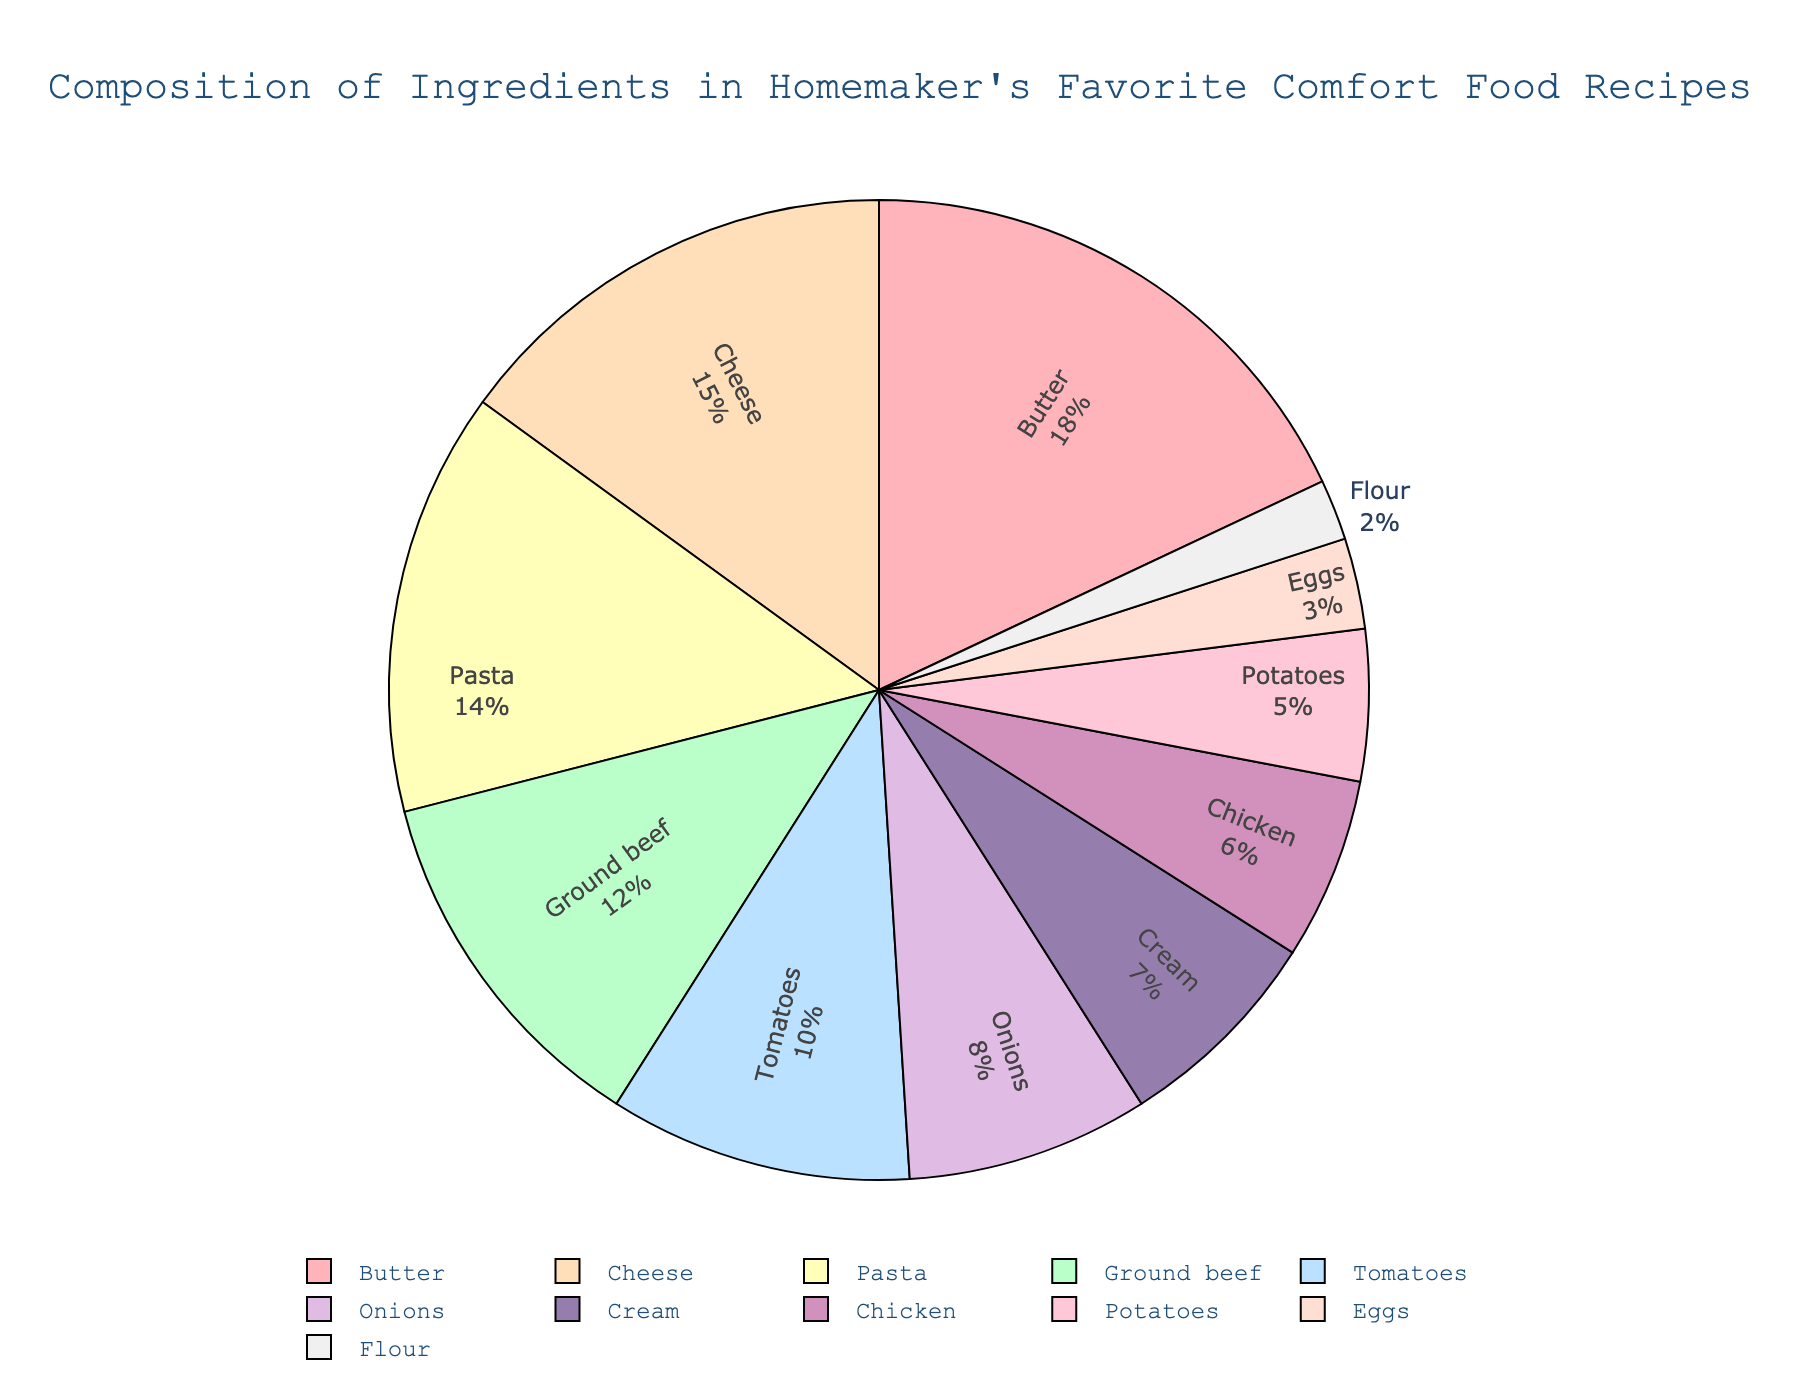What's the most prominent ingredient in the homemaker's comfort food recipes? To determine the most prominent ingredient, look for the largest slice in the pie chart. The largest slice represents Butter with 18%.
Answer: Butter Which two ingredients together make up more than 30% of the total composition? By identifying the percentages, we find the two largest components: Butter (18%) and Cheese (15%). Adding these percentages together (18% + 15%) gives 33%, which is more than 30%.
Answer: Butter and Cheese How does the percentage of Cream compare to that of Chicken? Compare the slices for Cream and Chicken. Cream is 7% while Chicken is 6%, making Cream 1% higher than Chicken.
Answer: Cream is 1% higher than Chicken What is the combined percentage of the least represented ingredients, Eggs, and Flour? Add the percentages for Eggs (3%) and Flour (2%). The combined total is 5%.
Answer: 5% Which ingredient has a larger proportion: Ground beef or Tomatoes? Compare the slices for Ground beef and Tomatoes. Ground beef represents 12%, and Tomatoes represent 10%, so Ground beef has a larger proportion.
Answer: Ground beef How much more significant is Pasta's percentage compared to that of Onions? Subtract the percentage of Onions (8%) from Pasta's (14%). The difference is 6%.
Answer: 6% What is the total percentage of ingredients related to dairy (Butter, Cheese, Cream)? Sum the percentages for Butter (18%), Cheese (15%), and Cream (7%). The total is 40%.
Answer: 40% What fraction of the pie chart is represented by non-dairy ingredients? Subtract the total percentage of dairy ingredients (40%) from 100%. The remaining percentage is 60%, indicating non-dairy ingredients.
Answer: 60% Which ingredient is represented with a portion between 10% and 15% in the pie chart? Identify ingredients between the percentages of 10% and 15%. Both Cheese (15%) and Pasta (14%) fall into this range.
Answer: Cheese and Pasta What is the visual difference in the colors of the highest and lowest percentage ingredients? The highest percentage ingredient, Butter, is pinkish, while the lowest percentage ingredient, Flour, is light grey. These colors provide a visual cue to distinguish their proportions.
Answer: Pinkish and light grey 